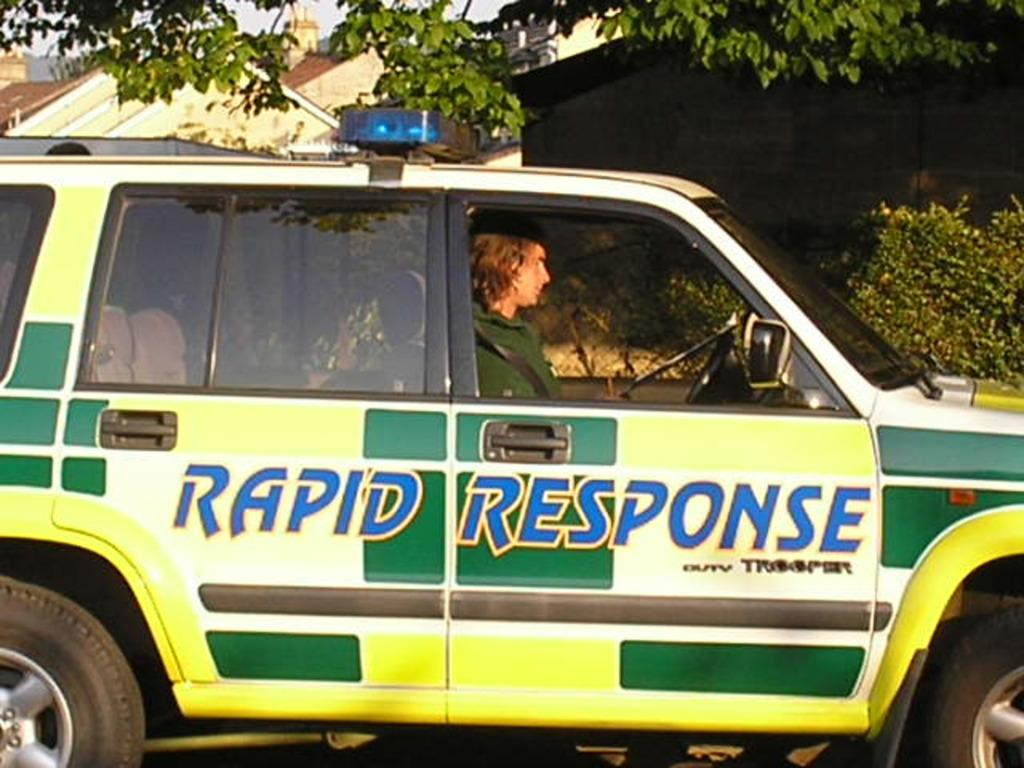What is the main subject of the image? The main subject of the image is a car. Can you describe the car's appearance? The car is green and yellow. Who is present in the car? There is a boy sitting in the car. What can be seen in the background of the image? There are green color trees in the background of the image. Where is the zoo located in the image? There is no zoo present in the image. What type of engine is used in the car? The type of engine used in the car is not visible in the image. 